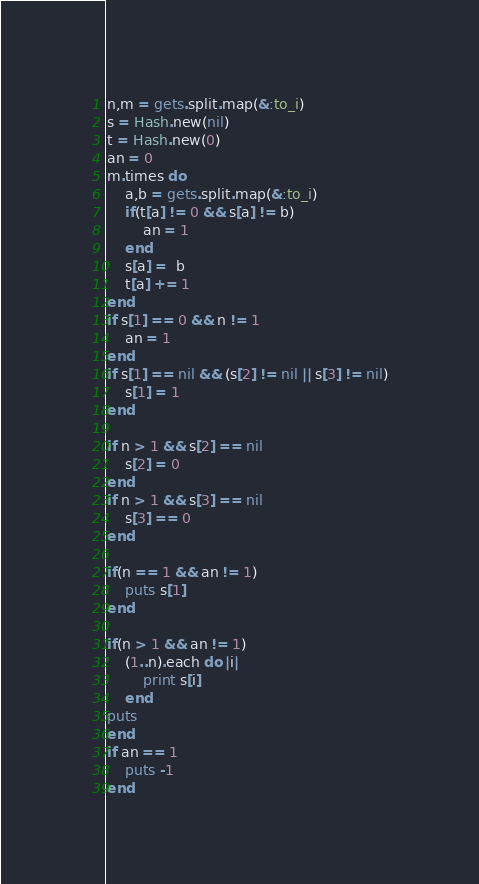<code> <loc_0><loc_0><loc_500><loc_500><_Ruby_>n,m = gets.split.map(&:to_i)
s = Hash.new(nil)
t = Hash.new(0)
an = 0
m.times do 
    a,b = gets.split.map(&:to_i)
    if(t[a] != 0 && s[a] != b)
        an = 1
    end
    s[a] =  b
    t[a] += 1
end
if s[1] == 0 && n != 1
    an = 1
end
if s[1] == nil && (s[2] != nil || s[3] != nil)
    s[1] = 1
end 

if n > 1 && s[2] == nil
    s[2] = 0
end
if n > 1 && s[3] == nil
    s[3] == 0
end

if(n == 1 && an != 1)
    puts s[1]
end

if(n > 1 && an != 1)
    (1..n).each do |i|
        print s[i]
    end
puts
end
if an == 1
    puts -1
end

</code> 